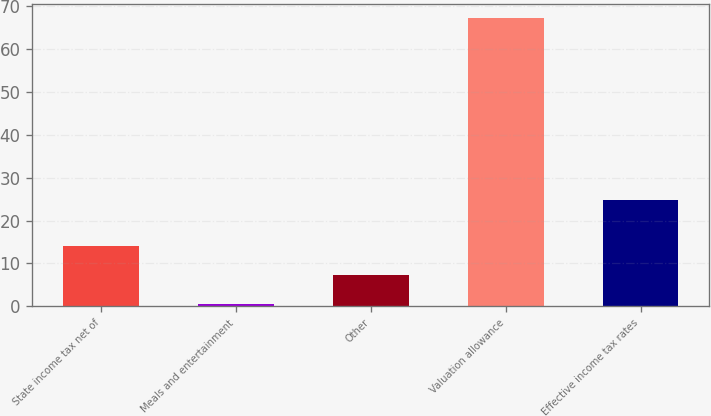Convert chart. <chart><loc_0><loc_0><loc_500><loc_500><bar_chart><fcel>State income tax net of<fcel>Meals and entertainment<fcel>Other<fcel>Valuation allowance<fcel>Effective income tax rates<nl><fcel>13.94<fcel>0.6<fcel>7.27<fcel>67.3<fcel>24.7<nl></chart> 